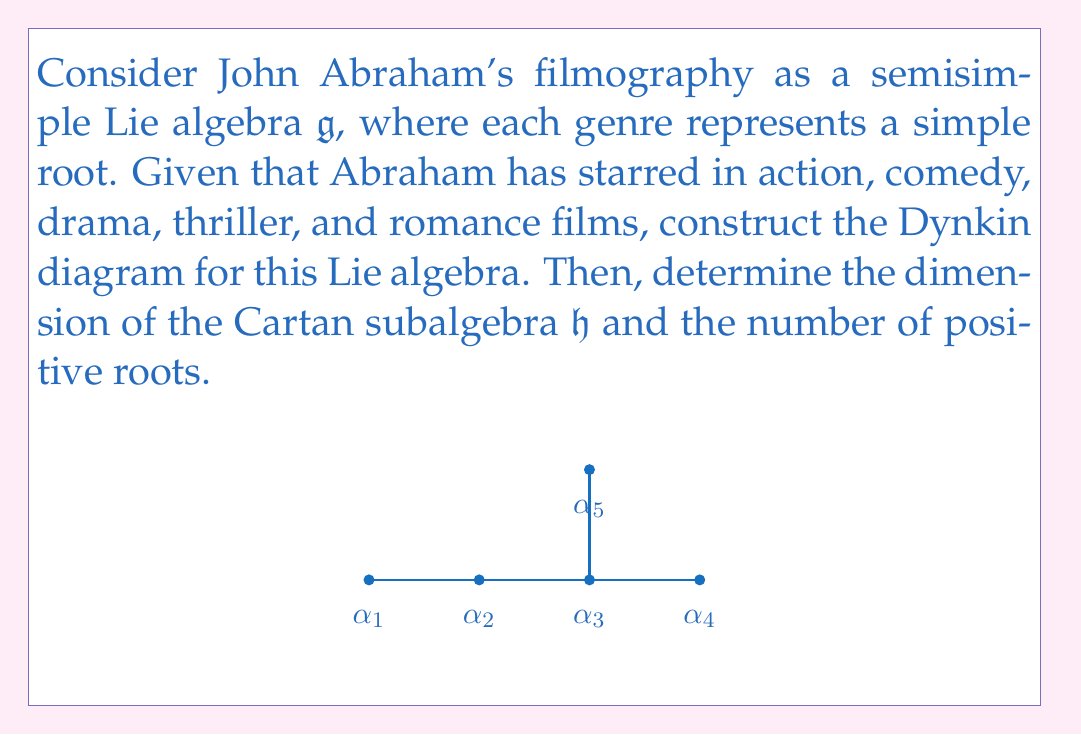Help me with this question. Let's approach this step-by-step:

1) First, we identify the simple roots corresponding to each genre:
   $\alpha_1$ (action), $\alpha_2$ (comedy), $\alpha_3$ (drama), $\alpha_4$ (thriller), $\alpha_5$ (romance)

2) The Dynkin diagram shown represents a Lie algebra of type $D_5$, which corresponds to the orthogonal Lie algebra $\mathfrak{so}(10)$.

3) For a semisimple Lie algebra, the dimension of the Cartan subalgebra $\mathfrak{h}$ is equal to the rank of the algebra, which is the number of simple roots. Here, we have 5 simple roots.

4) To find the number of positive roots, we can use the formula:
   Number of positive roots = $\frac{1}{2}(\text{dim}(\mathfrak{g}) - \text{rank}(\mathfrak{g}))$

5) For $D_5$, we know that $\text{dim}(\mathfrak{so}(10)) = \frac{10(10-1)}{2} = 45$

6) Therefore, the number of positive roots is:
   $\frac{1}{2}(45 - 5) = 20$

Thus, we have determined that the dimension of the Cartan subalgebra is 5, and the number of positive roots is 20.
Answer: $\text{dim}(\mathfrak{h}) = 5$, Number of positive roots $= 20$ 